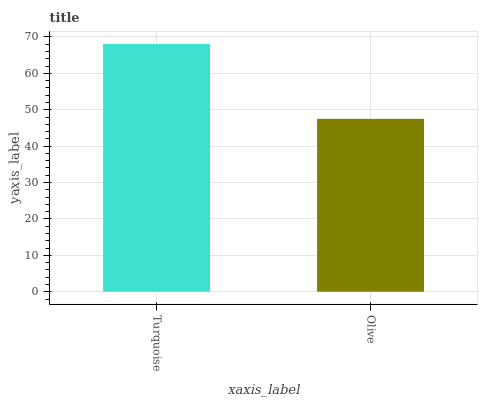Is Olive the maximum?
Answer yes or no. No. Is Turquoise greater than Olive?
Answer yes or no. Yes. Is Olive less than Turquoise?
Answer yes or no. Yes. Is Olive greater than Turquoise?
Answer yes or no. No. Is Turquoise less than Olive?
Answer yes or no. No. Is Turquoise the high median?
Answer yes or no. Yes. Is Olive the low median?
Answer yes or no. Yes. Is Olive the high median?
Answer yes or no. No. Is Turquoise the low median?
Answer yes or no. No. 